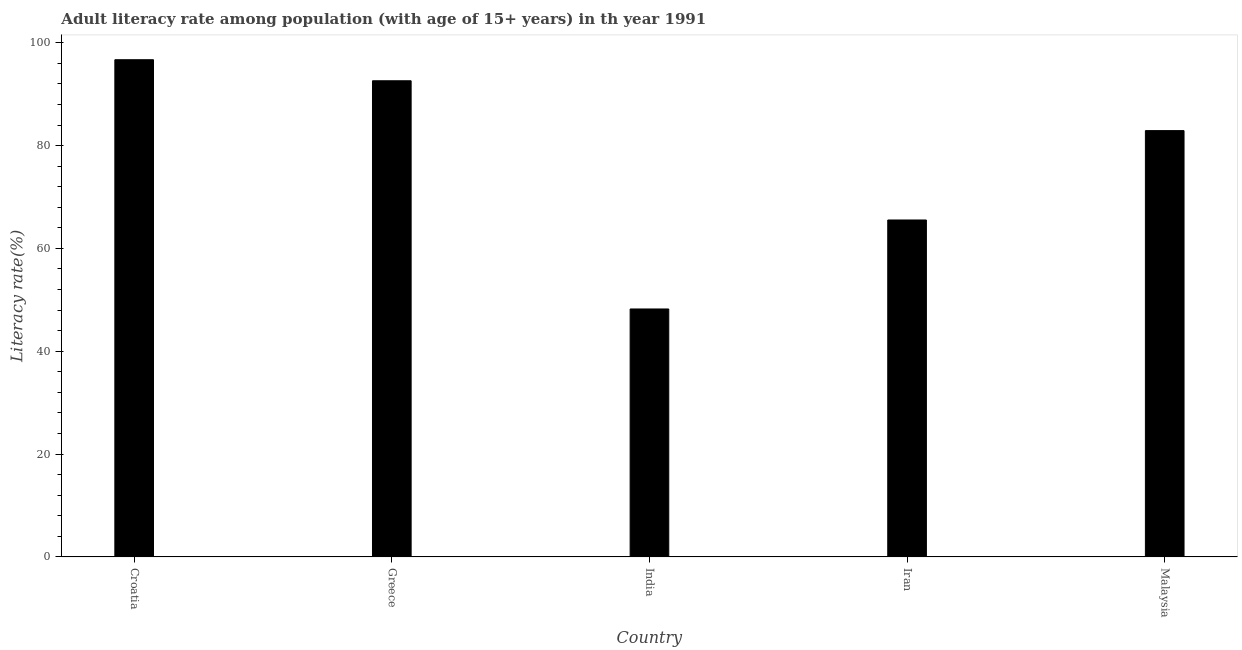Does the graph contain grids?
Make the answer very short. No. What is the title of the graph?
Offer a terse response. Adult literacy rate among population (with age of 15+ years) in th year 1991. What is the label or title of the Y-axis?
Give a very brief answer. Literacy rate(%). What is the adult literacy rate in India?
Offer a terse response. 48.22. Across all countries, what is the maximum adult literacy rate?
Offer a terse response. 96.7. Across all countries, what is the minimum adult literacy rate?
Your response must be concise. 48.22. In which country was the adult literacy rate maximum?
Give a very brief answer. Croatia. What is the sum of the adult literacy rate?
Provide a succinct answer. 385.98. What is the difference between the adult literacy rate in India and Malaysia?
Ensure brevity in your answer.  -34.69. What is the average adult literacy rate per country?
Give a very brief answer. 77.2. What is the median adult literacy rate?
Ensure brevity in your answer.  82.92. What is the ratio of the adult literacy rate in Greece to that in India?
Your answer should be compact. 1.92. Is the difference between the adult literacy rate in Croatia and India greater than the difference between any two countries?
Ensure brevity in your answer.  Yes. What is the difference between the highest and the second highest adult literacy rate?
Make the answer very short. 4.09. What is the difference between the highest and the lowest adult literacy rate?
Offer a very short reply. 48.48. How many bars are there?
Offer a very short reply. 5. Are all the bars in the graph horizontal?
Offer a very short reply. No. What is the difference between two consecutive major ticks on the Y-axis?
Make the answer very short. 20. Are the values on the major ticks of Y-axis written in scientific E-notation?
Make the answer very short. No. What is the Literacy rate(%) of Croatia?
Ensure brevity in your answer.  96.7. What is the Literacy rate(%) of Greece?
Provide a succinct answer. 92.61. What is the Literacy rate(%) in India?
Your answer should be compact. 48.22. What is the Literacy rate(%) of Iran?
Your response must be concise. 65.53. What is the Literacy rate(%) of Malaysia?
Make the answer very short. 82.92. What is the difference between the Literacy rate(%) in Croatia and Greece?
Make the answer very short. 4.09. What is the difference between the Literacy rate(%) in Croatia and India?
Your answer should be very brief. 48.48. What is the difference between the Literacy rate(%) in Croatia and Iran?
Your response must be concise. 31.17. What is the difference between the Literacy rate(%) in Croatia and Malaysia?
Make the answer very short. 13.79. What is the difference between the Literacy rate(%) in Greece and India?
Your answer should be compact. 44.39. What is the difference between the Literacy rate(%) in Greece and Iran?
Offer a terse response. 27.08. What is the difference between the Literacy rate(%) in Greece and Malaysia?
Provide a succinct answer. 9.7. What is the difference between the Literacy rate(%) in India and Iran?
Ensure brevity in your answer.  -17.31. What is the difference between the Literacy rate(%) in India and Malaysia?
Your answer should be compact. -34.69. What is the difference between the Literacy rate(%) in Iran and Malaysia?
Make the answer very short. -17.38. What is the ratio of the Literacy rate(%) in Croatia to that in Greece?
Keep it short and to the point. 1.04. What is the ratio of the Literacy rate(%) in Croatia to that in India?
Make the answer very short. 2. What is the ratio of the Literacy rate(%) in Croatia to that in Iran?
Keep it short and to the point. 1.48. What is the ratio of the Literacy rate(%) in Croatia to that in Malaysia?
Offer a terse response. 1.17. What is the ratio of the Literacy rate(%) in Greece to that in India?
Keep it short and to the point. 1.92. What is the ratio of the Literacy rate(%) in Greece to that in Iran?
Your answer should be very brief. 1.41. What is the ratio of the Literacy rate(%) in Greece to that in Malaysia?
Your answer should be very brief. 1.12. What is the ratio of the Literacy rate(%) in India to that in Iran?
Keep it short and to the point. 0.74. What is the ratio of the Literacy rate(%) in India to that in Malaysia?
Give a very brief answer. 0.58. What is the ratio of the Literacy rate(%) in Iran to that in Malaysia?
Make the answer very short. 0.79. 